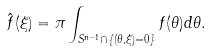Convert formula to latex. <formula><loc_0><loc_0><loc_500><loc_500>\hat { f } ( \xi ) = \pi \int _ { S ^ { n - 1 } \cap \{ ( \theta , \xi ) = 0 \} } f ( \theta ) d \theta .</formula> 